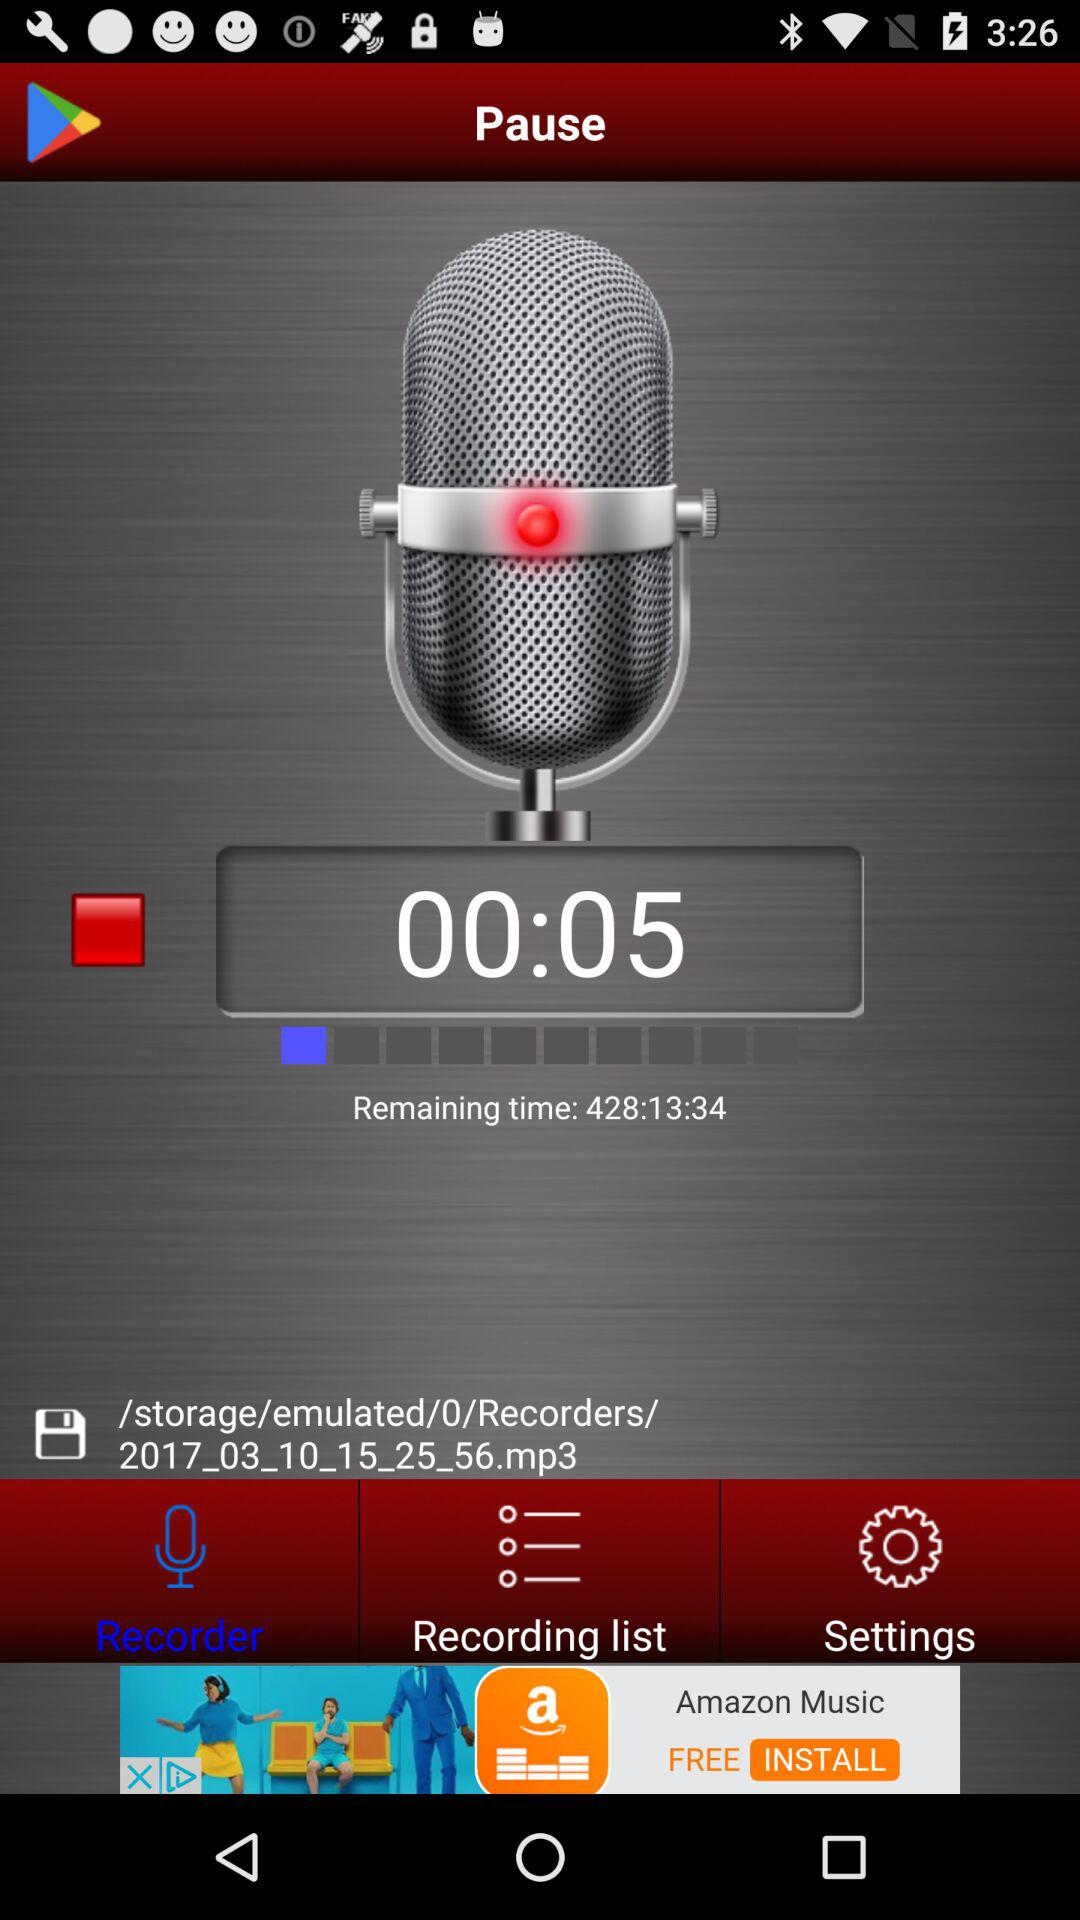What is the name of the MP3 file? The name of the MP3 file is "2017_03_10_15_25_56.mp3". 